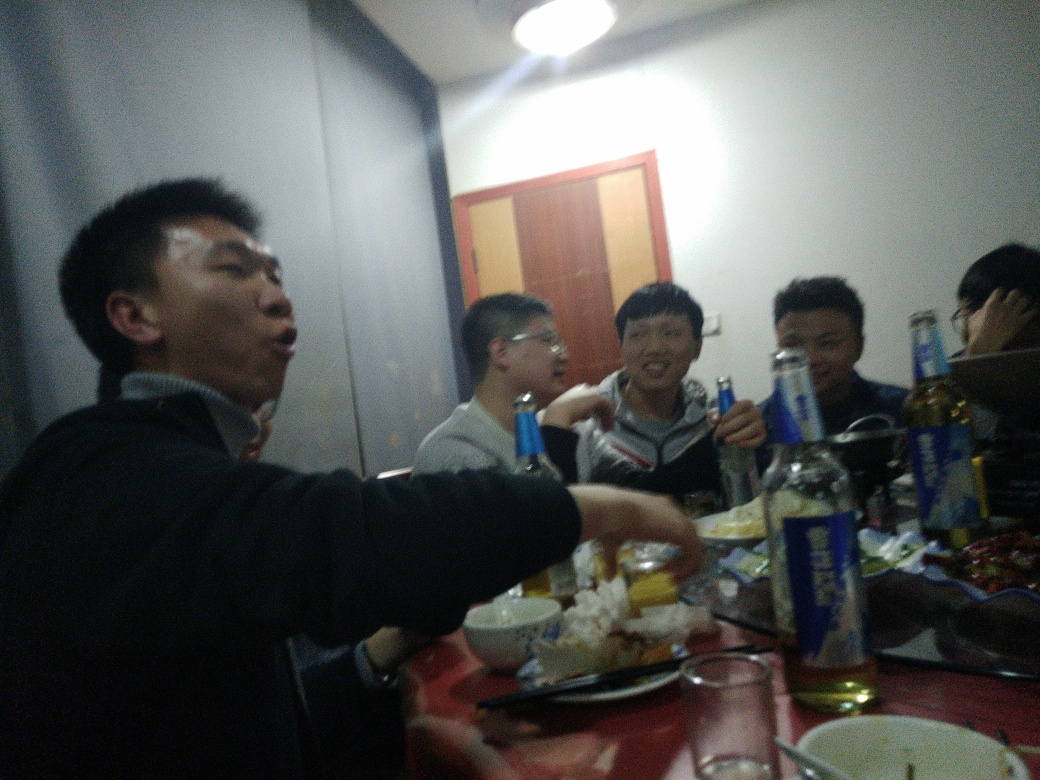What kind of gathering does this image appear to depict? This image seems to capture a casual and social gathering, possibly among friends or colleagues. The presence of food and beverage on the table suggests it might be a dining event, such as a dinner or celebration held indoor, contributing to a convivial atmosphere. Are there any indications of the location or cultural context for this gathering? While specific location details are not clear, there are hints that could suggest the cultural context. For example, the style of drink bottles, the visible dishes, and the general ambiance might indicate a regional preference or local custom. However, without more context or visible cultural markers, it would be challenging to pinpoint the exact location or culture. 